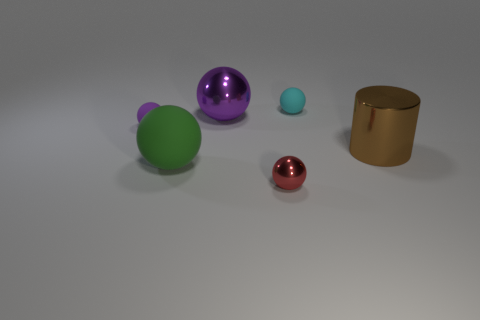There is a thing on the right side of the small cyan sphere; how many spheres are in front of it?
Your response must be concise. 2. Is the shape of the tiny object that is in front of the big brown cylinder the same as the tiny purple object that is in front of the cyan object?
Your response must be concise. Yes. There is a large green matte object; how many big purple objects are left of it?
Give a very brief answer. 0. Is the material of the big sphere that is in front of the brown object the same as the cylinder?
Keep it short and to the point. No. There is another large object that is the same shape as the purple metal object; what color is it?
Provide a succinct answer. Green. The green object has what shape?
Your answer should be very brief. Sphere. How many things are either tiny cyan rubber balls or large purple rubber cylinders?
Provide a short and direct response. 1. Does the metallic sphere that is behind the red shiny thing have the same color as the tiny rubber object that is in front of the purple metallic thing?
Give a very brief answer. Yes. How many other things are the same shape as the purple rubber object?
Your response must be concise. 4. Is there a big shiny cylinder?
Give a very brief answer. Yes. 